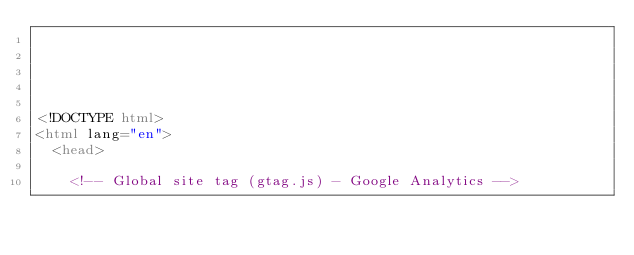Convert code to text. <code><loc_0><loc_0><loc_500><loc_500><_HTML_>




<!DOCTYPE html>
<html lang="en">
  <head>

	<!-- Global site tag (gtag.js) - Google Analytics --></code> 